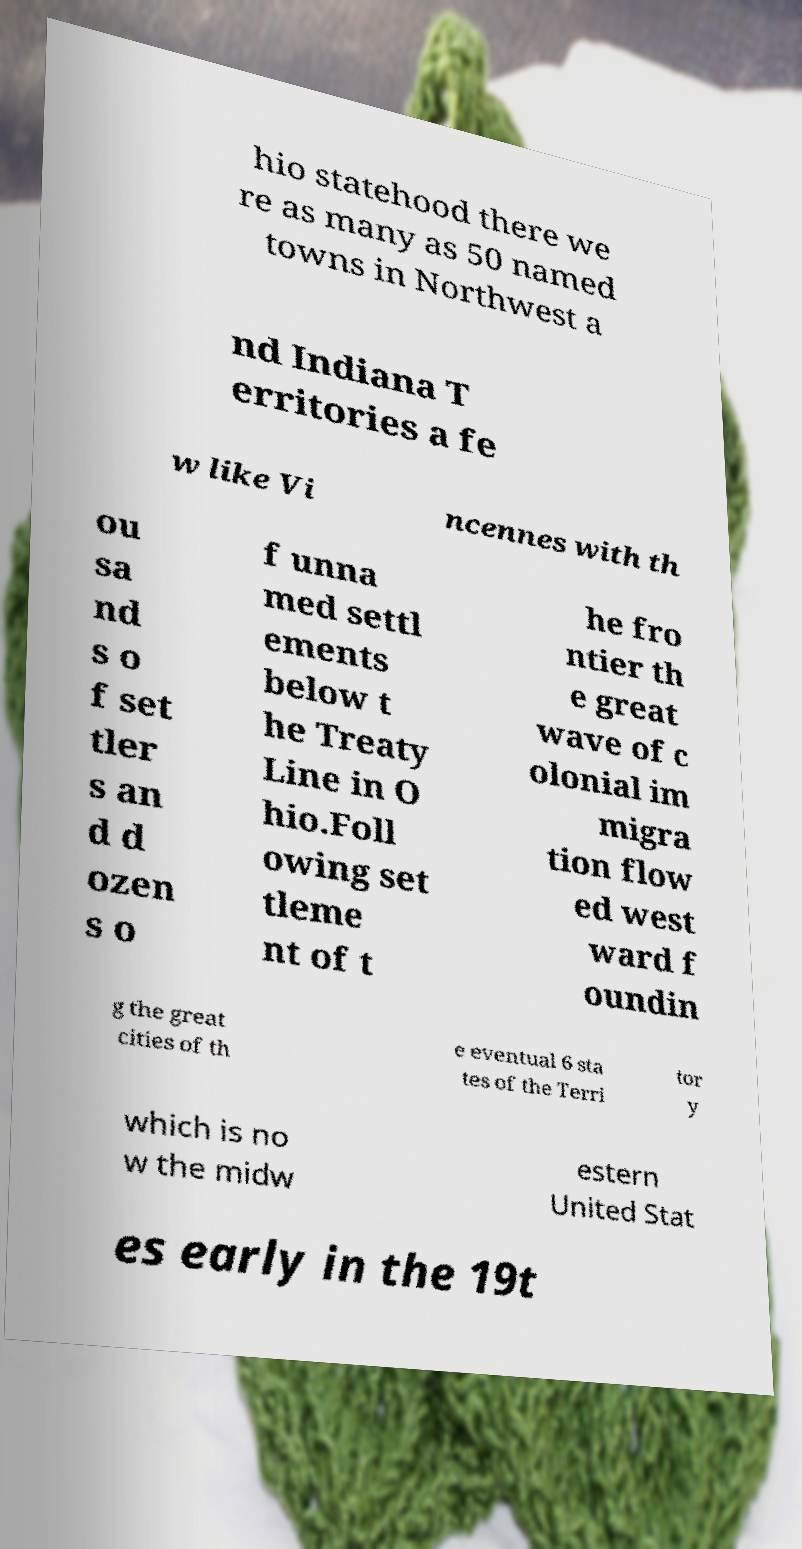Can you accurately transcribe the text from the provided image for me? hio statehood there we re as many as 50 named towns in Northwest a nd Indiana T erritories a fe w like Vi ncennes with th ou sa nd s o f set tler s an d d ozen s o f unna med settl ements below t he Treaty Line in O hio.Foll owing set tleme nt of t he fro ntier th e great wave of c olonial im migra tion flow ed west ward f oundin g the great cities of th e eventual 6 sta tes of the Terri tor y which is no w the midw estern United Stat es early in the 19t 